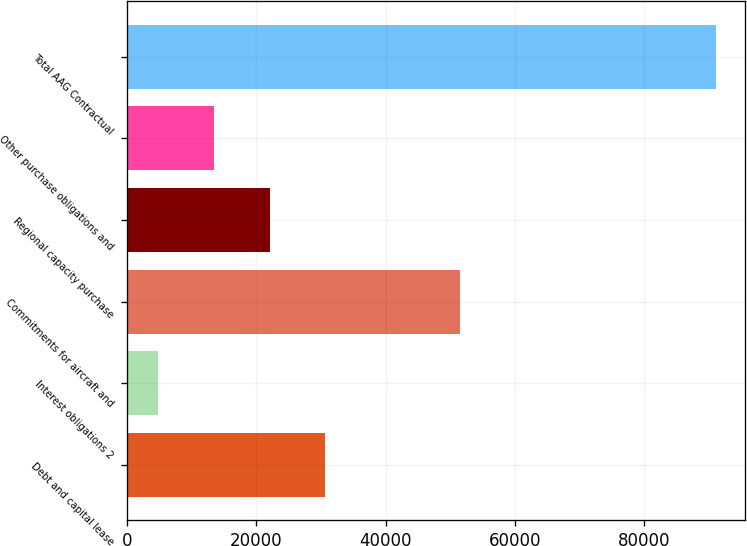Convert chart to OTSL. <chart><loc_0><loc_0><loc_500><loc_500><bar_chart><fcel>Debt and capital lease<fcel>Interest obligations 2<fcel>Commitments for aircraft and<fcel>Regional capacity purchase<fcel>Other purchase obligations and<fcel>Total AAG Contractual<nl><fcel>30685.9<fcel>4810<fcel>51581<fcel>22060.6<fcel>13435.3<fcel>91063<nl></chart> 